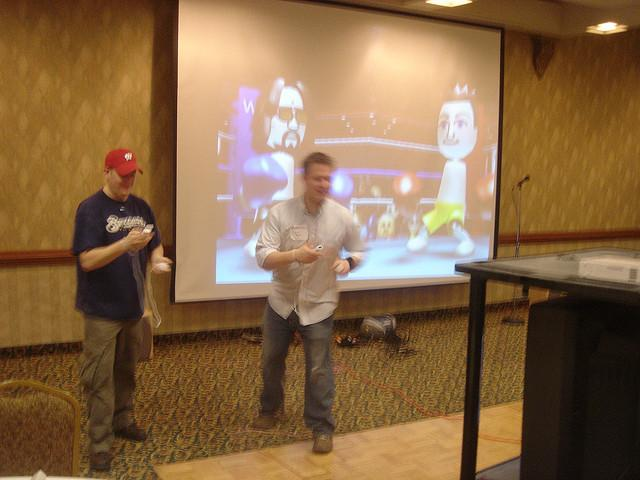Which player is controlling the avatar with the blue gloves? right 